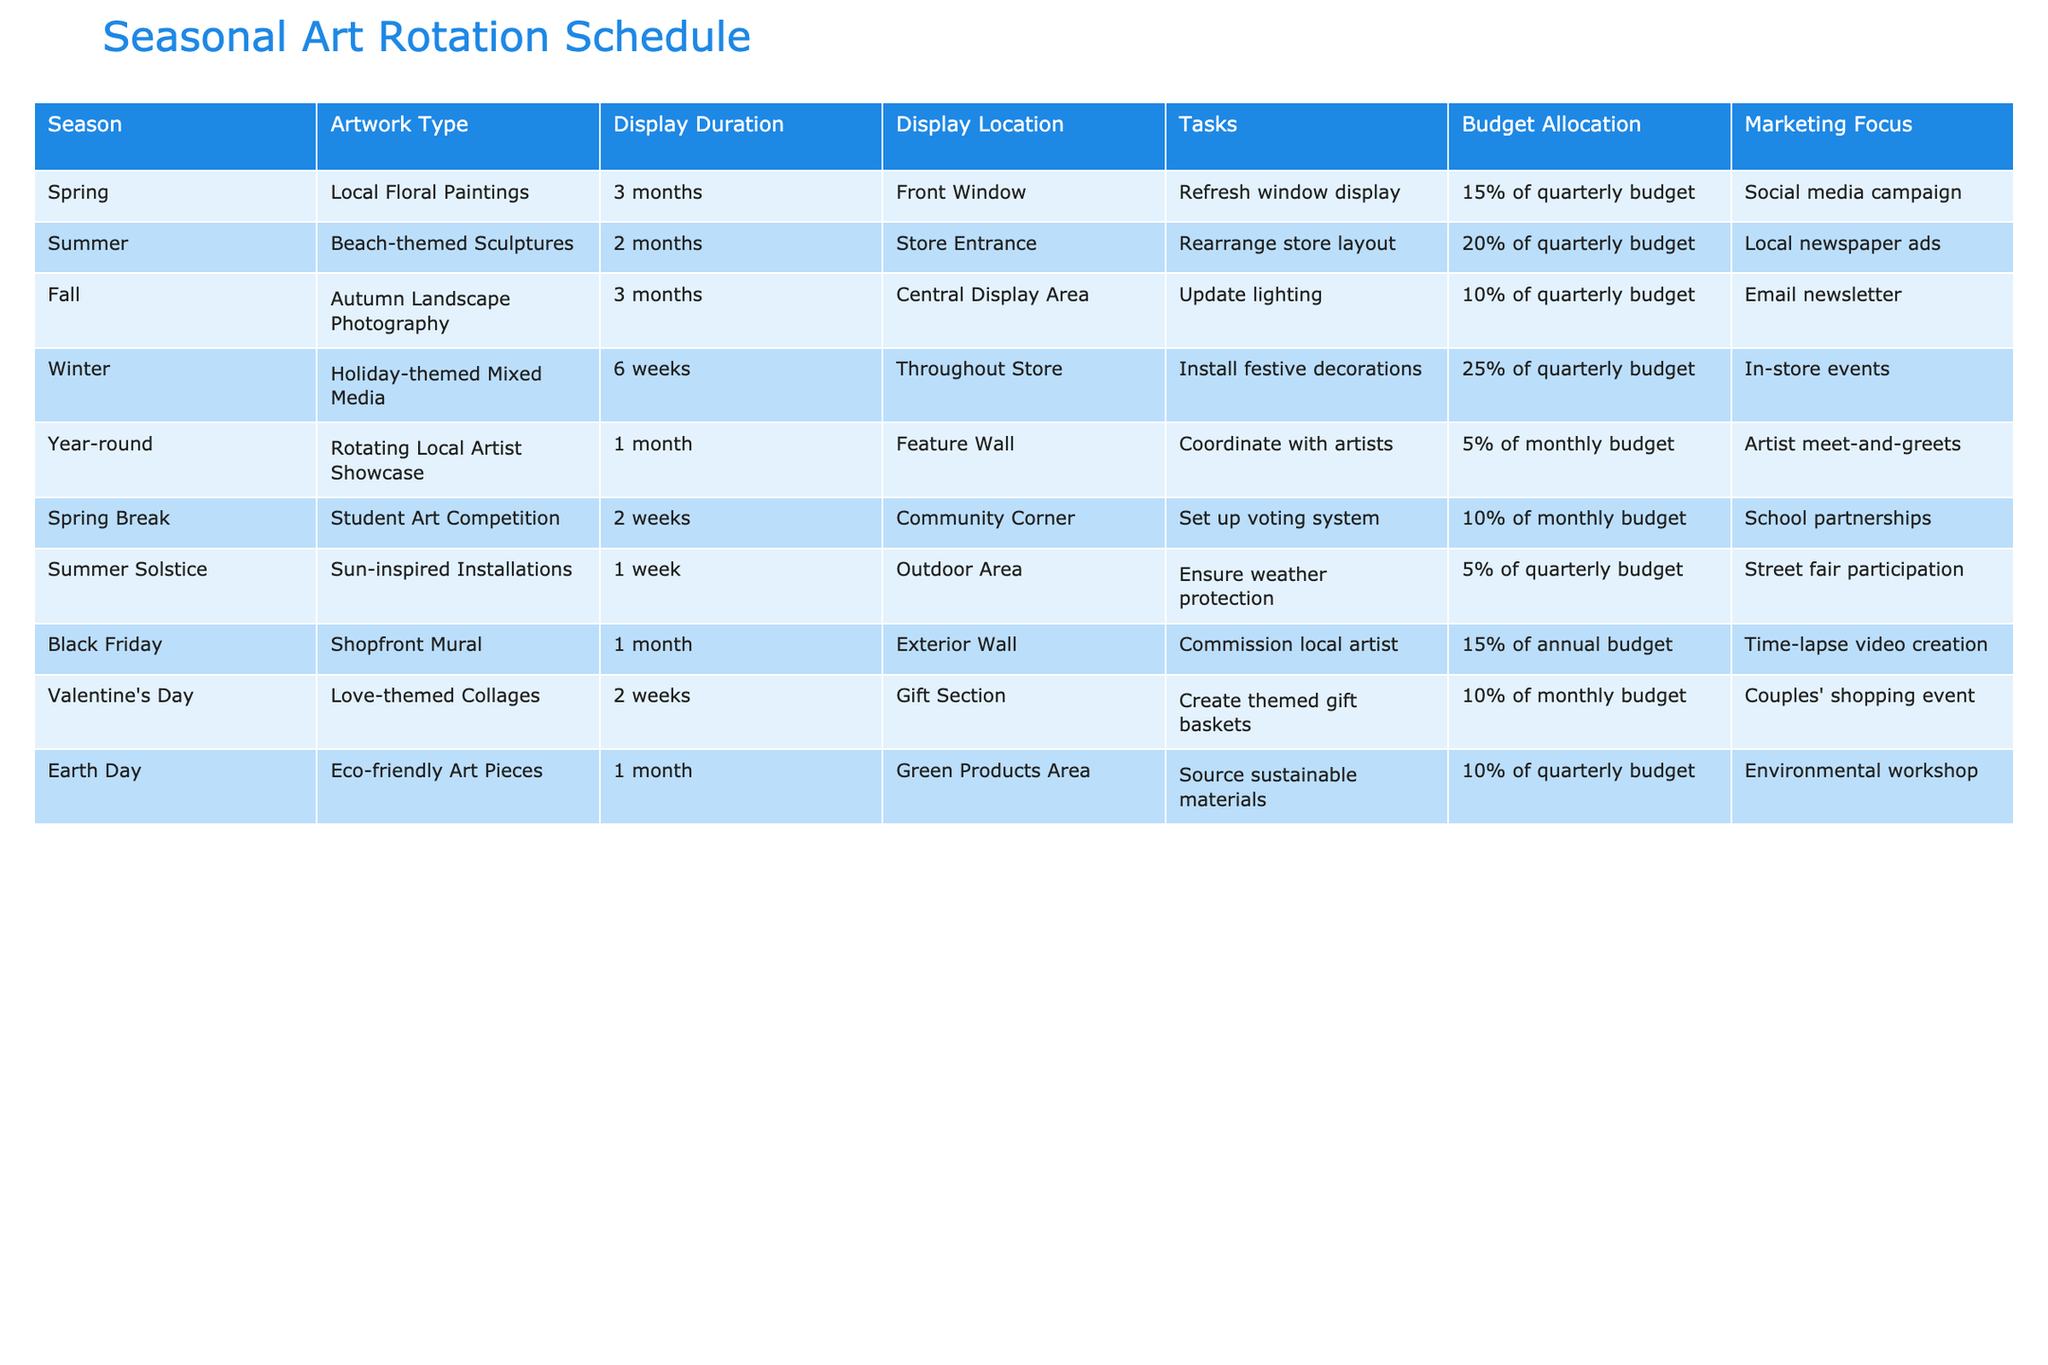What is the display duration for the Holiday-themed Mixed Media art? The table shows the row for Winter, where the Holiday-themed Mixed Media art has a display duration of 6 weeks.
Answer: 6 weeks Which season features Love-themed Collages? The table indicates that Love-themed Collages are featured on Valentine's Day, which falls in the Spring season.
Answer: Spring How much of the budget is allocated for the Autumn Landscape Photography display? According to the table, the budget allocation for Autumn Landscape Photography is 10% of the quarterly budget.
Answer: 10% of the quarterly budget Is there a seasonal art display that focuses on eco-friendly art pieces? Yes, the table includes a row for Earth Day, where Eco-friendly Art Pieces are displayed, confirming that such a display exists.
Answer: Yes What is the total budget allocation percentage for displays during Spring? The table lists two entries for Spring: Local Floral Paintings (15% of quarterly budget) and Student Art Competition (10% of monthly budget). Adding these gives 15 + 10 = 25%.
Answer: 25% During which month is the Shopfront Mural displayed, and what is the marketing focus? The table shows the Shopfront Mural is displayed in November (Black Friday) and the marketing focus is on time-lapse video creation.
Answer: November, time-lapse video creation What is the average budget allocation for the Summer displays (Beach-themed Sculptures and Sun-inspired Installations)? The budget allocation for summer consists of two entries: Beach-themed Sculptures (20% of quarterly budget) and Sun-inspired Installations (5% of quarterly budget). The average is (20 + 5) / 2 = 12.5%.
Answer: 12.5% In which display location is the rotating local artist showcase held? The table states that the rotating local artist showcase is held at the Feature Wall.
Answer: Feature Wall How does the marketing focus differ between the Holiday-themed Mixed Media and the Autumn Landscape Photography displays? The Holiday-themed Mixed Media focuses on in-store events while the Autumn Landscape Photography focuses on an email newsletter. This shows different marketing strategies for these two seasons.
Answer: Different strategies 